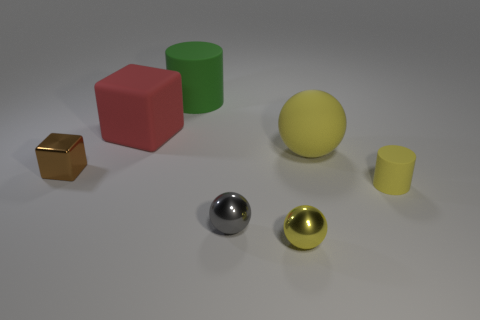Add 2 big cubes. How many objects exist? 9 Subtract all cylinders. How many objects are left? 5 Subtract 0 cyan cylinders. How many objects are left? 7 Subtract all tiny green matte things. Subtract all large green cylinders. How many objects are left? 6 Add 6 small rubber cylinders. How many small rubber cylinders are left? 7 Add 3 big purple metal cylinders. How many big purple metal cylinders exist? 3 